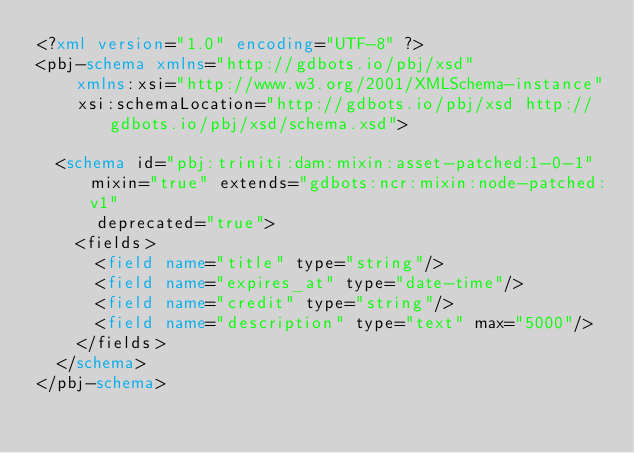<code> <loc_0><loc_0><loc_500><loc_500><_XML_><?xml version="1.0" encoding="UTF-8" ?>
<pbj-schema xmlns="http://gdbots.io/pbj/xsd"
    xmlns:xsi="http://www.w3.org/2001/XMLSchema-instance"
    xsi:schemaLocation="http://gdbots.io/pbj/xsd http://gdbots.io/pbj/xsd/schema.xsd">

  <schema id="pbj:triniti:dam:mixin:asset-patched:1-0-1" mixin="true" extends="gdbots:ncr:mixin:node-patched:v1"
      deprecated="true">
    <fields>
      <field name="title" type="string"/>
      <field name="expires_at" type="date-time"/>
      <field name="credit" type="string"/>
      <field name="description" type="text" max="5000"/>
    </fields>
  </schema>
</pbj-schema>
</code> 